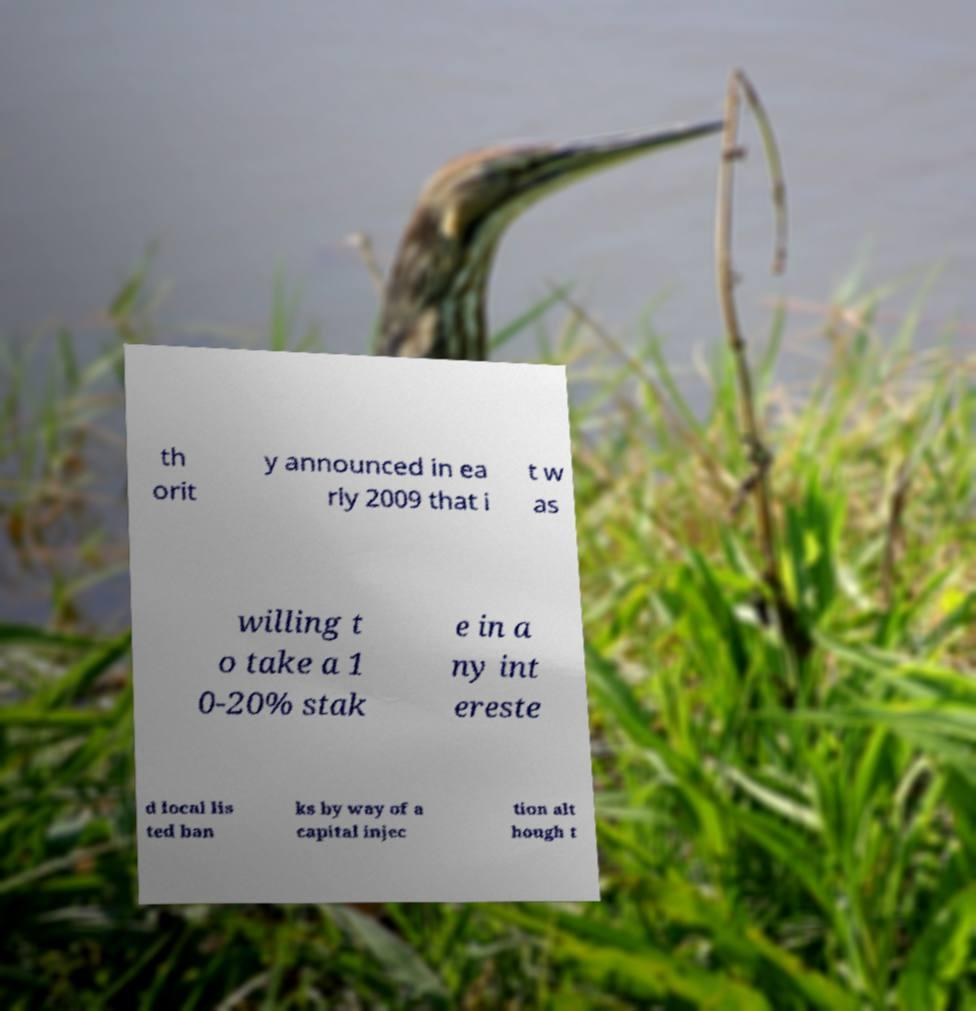There's text embedded in this image that I need extracted. Can you transcribe it verbatim? th orit y announced in ea rly 2009 that i t w as willing t o take a 1 0-20% stak e in a ny int ereste d local lis ted ban ks by way of a capital injec tion alt hough t 